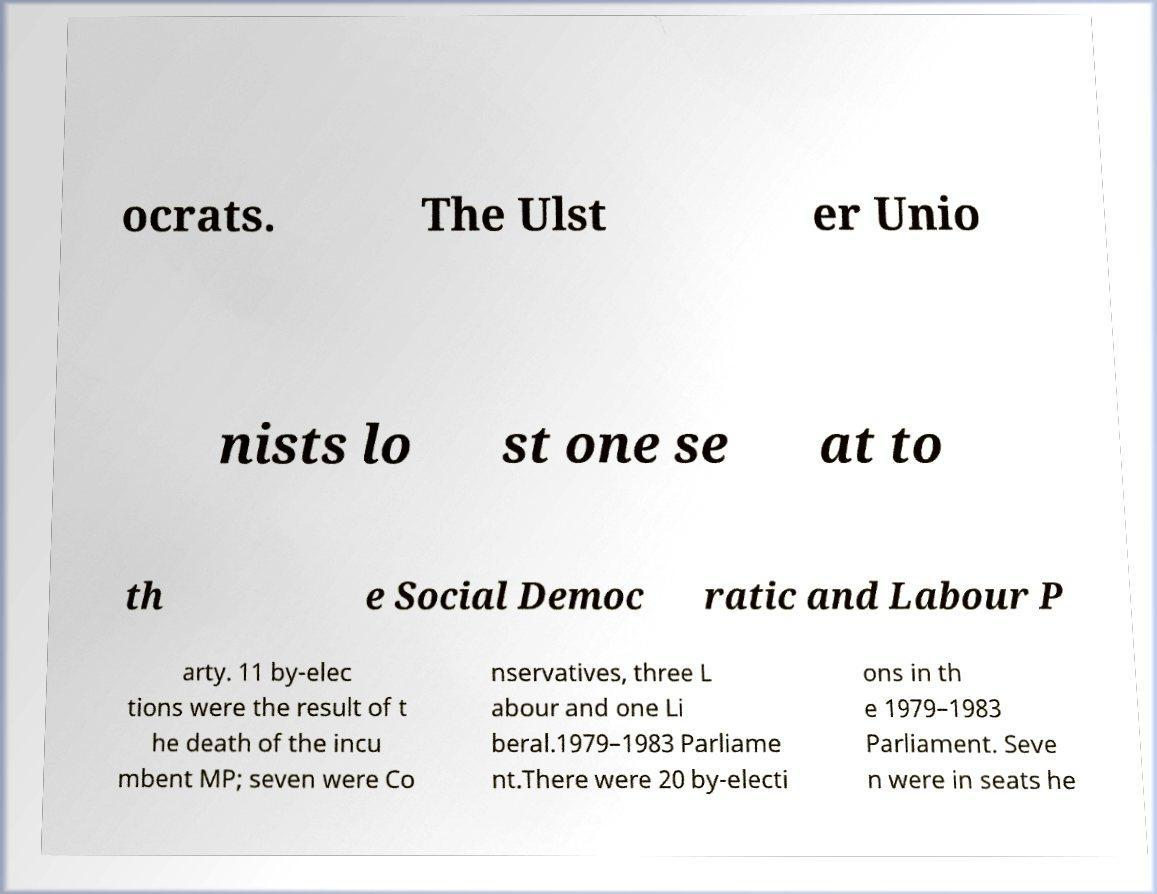There's text embedded in this image that I need extracted. Can you transcribe it verbatim? ocrats. The Ulst er Unio nists lo st one se at to th e Social Democ ratic and Labour P arty. 11 by-elec tions were the result of t he death of the incu mbent MP; seven were Co nservatives, three L abour and one Li beral.1979–1983 Parliame nt.There were 20 by-electi ons in th e 1979–1983 Parliament. Seve n were in seats he 